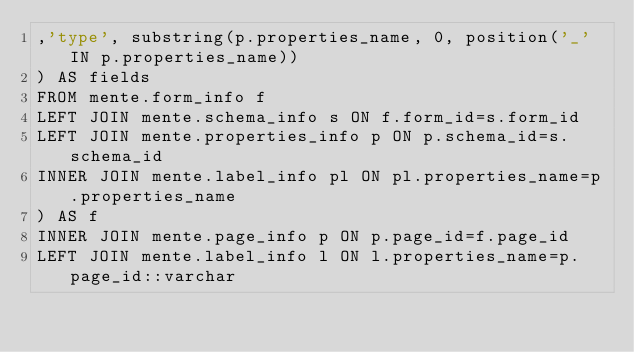<code> <loc_0><loc_0><loc_500><loc_500><_SQL_>,'type', substring(p.properties_name, 0, position('_' IN p.properties_name))
) AS fields
FROM mente.form_info f
LEFT JOIN mente.schema_info s ON f.form_id=s.form_id
LEFT JOIN mente.properties_info p ON p.schema_id=s.schema_id
INNER JOIN mente.label_info pl ON pl.properties_name=p.properties_name
) AS f
INNER JOIN mente.page_info p ON p.page_id=f.page_id
LEFT JOIN mente.label_info l ON l.properties_name=p.page_id::varchar</code> 